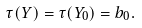Convert formula to latex. <formula><loc_0><loc_0><loc_500><loc_500>\tau ( Y ) = \tau ( Y _ { 0 } ) = b _ { 0 } .</formula> 